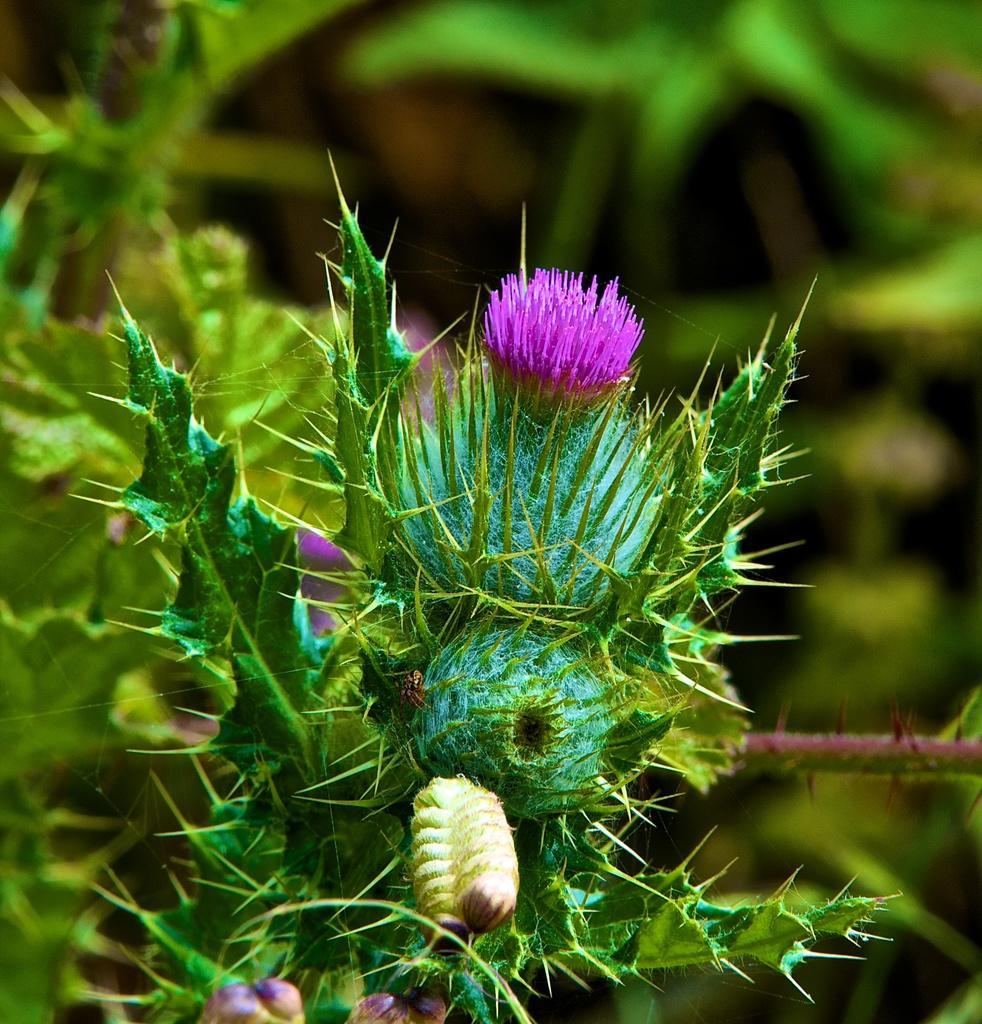In one or two sentences, can you explain what this image depicts? Here in this picture in the front we can see flowers present on plant and behind that also we can see other plants and trees in blurry manner and in the front we can see a bee present on the flower. 